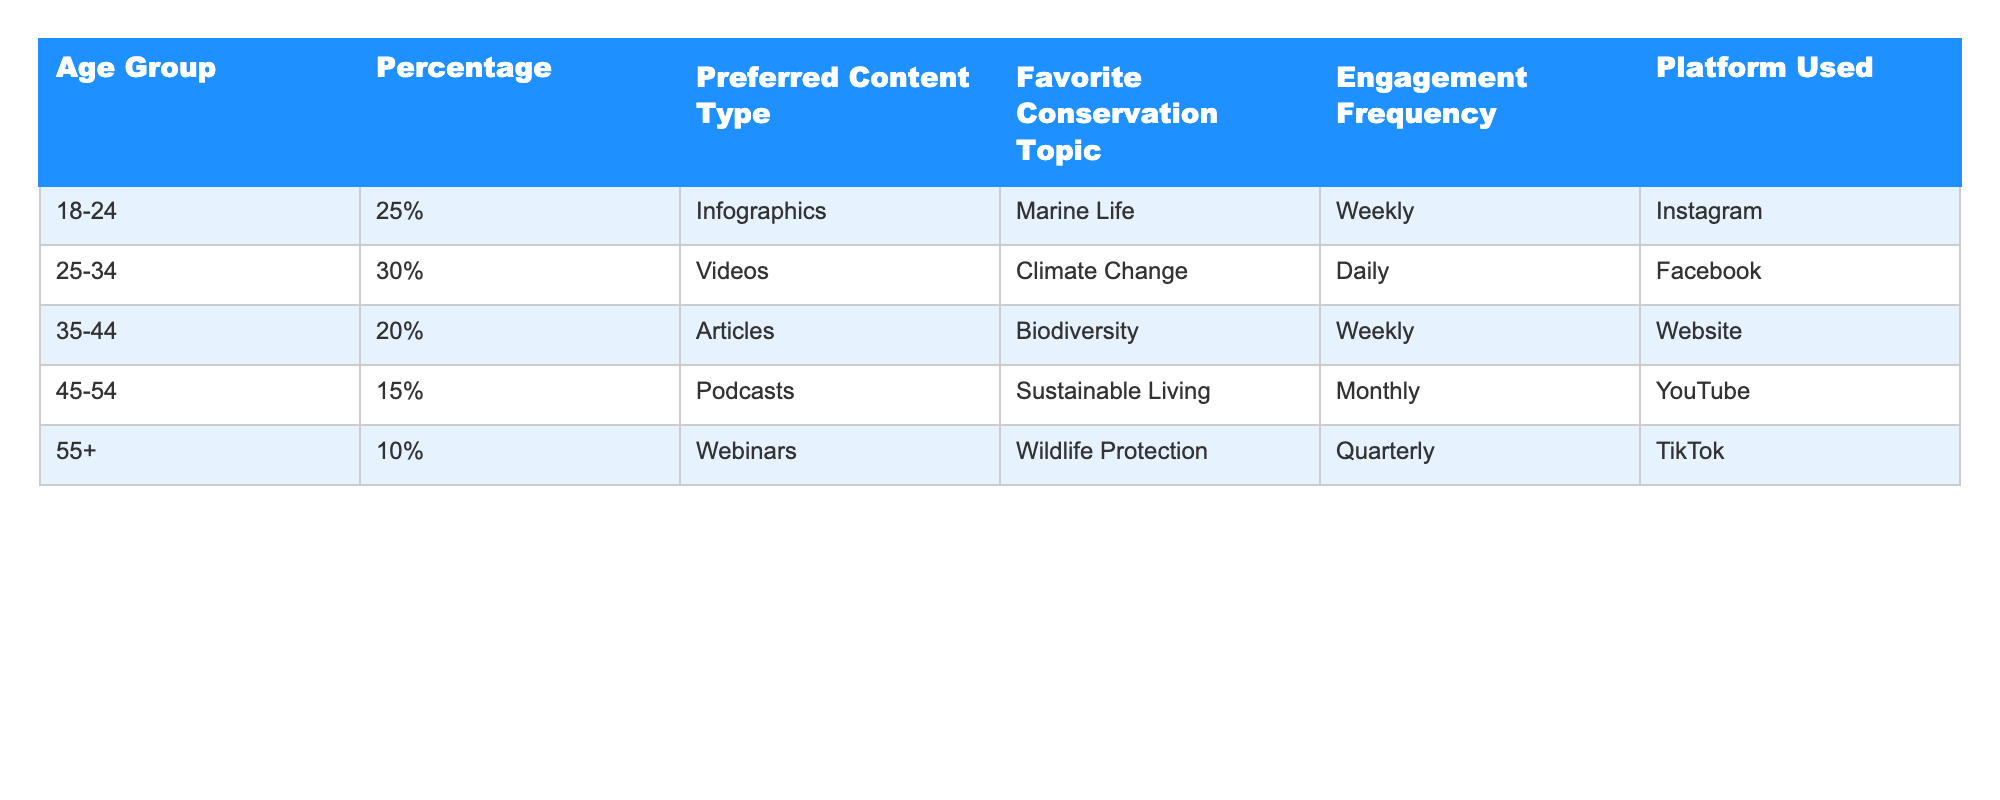What percentage of users are aged 25-34? The table directly shows that 30% of users belong to the age group 25-34.
Answer: 30% What is the preferred content type for the 45-54 age group? According to the table, users aged 45-54 prefer Podcasts as their content type.
Answer: Podcasts Which age group has the least engagement frequency? The 55+ age group engages quarterly, which is less frequent compared to all other age groups listed in the table.
Answer: 55+ What is the favorite conservation topic of users aged 35-44? The table indicates that users in the 35-44 age group favor Biodiversity as their conservation topic.
Answer: Biodiversity How many age groups prefer weekly engagement frequency? The age groups 18-24 and 35-44 both prefer weekly engagement frequency, totaling two groups.
Answer: 2 What is the total percentage of users who prefer content types other than infographics? Totaling the percentages: 30% (Videos) + 20% (Articles) + 15% (Podcasts) + 10% (Webinars) equals 75%.
Answer: 75% Is there any age group that prefers Webinars as their favorite content type? Yes, the 55+ age group prefers Webinars according to the table.
Answer: Yes Which platform is most commonly used by the 25-34 age group? The table specifies that the 25-34 age group primarily uses Facebook as their platform.
Answer: Facebook If we compare engagement frequency, which age group engages the least? The 55+ age group engages quarterly, which is less frequent than all other age groups mentioned, indicating they engage the least.
Answer: 55+ What is the favorite conservation topic of the user demographic that engages daily? The 25-34 age group, which engages daily, has Climate Change as their favorite conservation topic according to the table.
Answer: Climate Change 